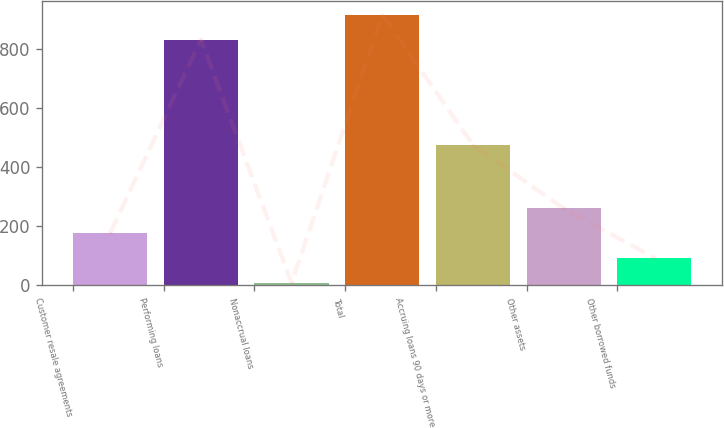Convert chart to OTSL. <chart><loc_0><loc_0><loc_500><loc_500><bar_chart><fcel>Customer resale agreements<fcel>Performing loans<fcel>Nonaccrual loans<fcel>Total<fcel>Accruing loans 90 days or more<fcel>Other assets<fcel>Other borrowed funds<nl><fcel>176.6<fcel>832<fcel>7<fcel>915.6<fcel>475<fcel>260.2<fcel>93<nl></chart> 